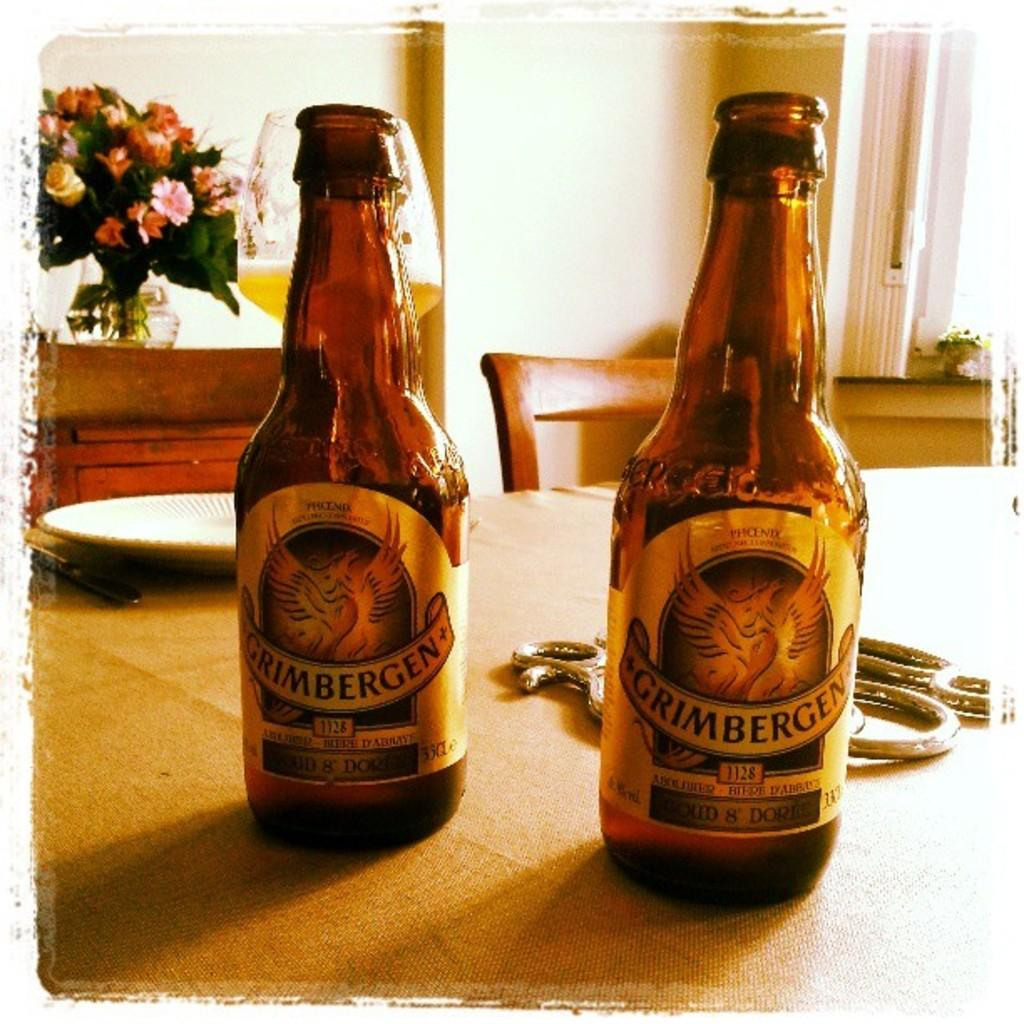<image>
Write a terse but informative summary of the picture. two bottles of grimbergen 1128 next to each other on a table 